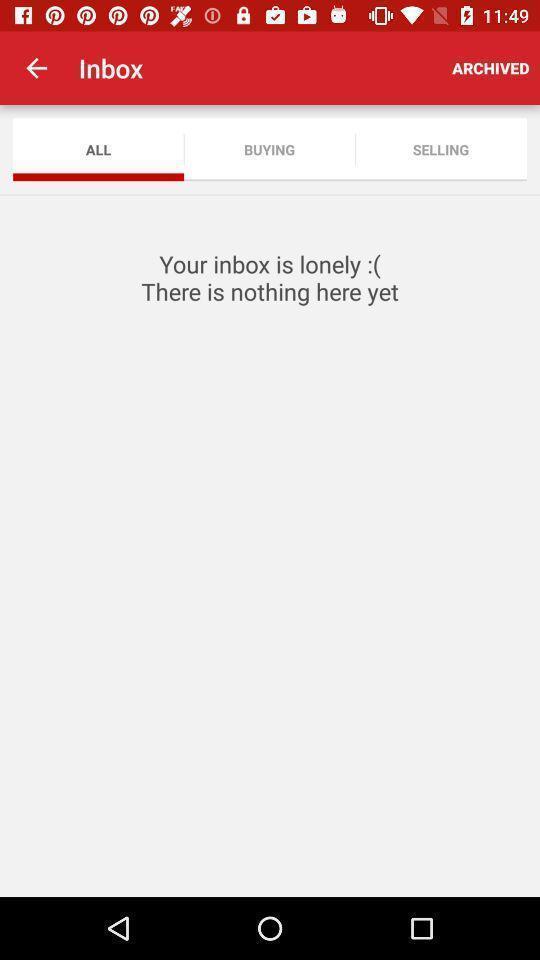Describe the content in this image. Page shows the empty inbox list on social app. 